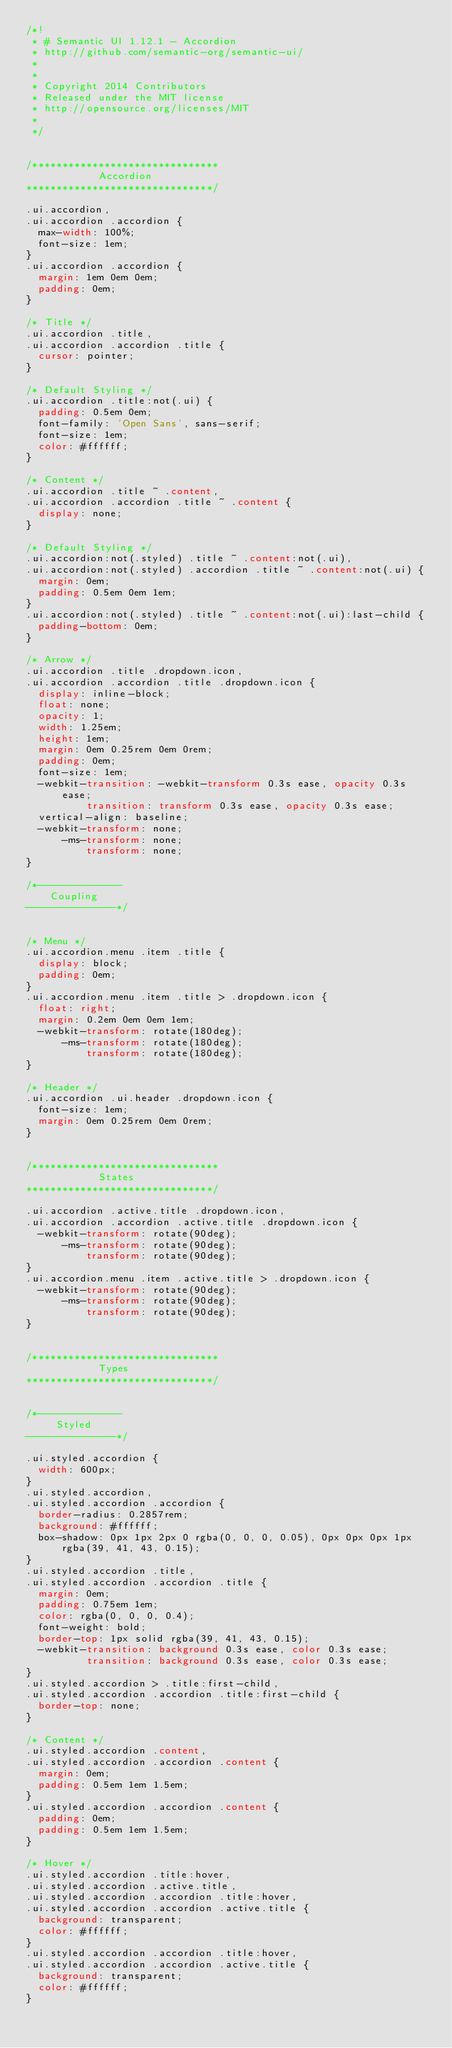<code> <loc_0><loc_0><loc_500><loc_500><_CSS_>/*!
 * # Semantic UI 1.12.1 - Accordion
 * http://github.com/semantic-org/semantic-ui/
 *
 *
 * Copyright 2014 Contributors
 * Released under the MIT license
 * http://opensource.org/licenses/MIT
 *
 */


/*******************************
            Accordion
*******************************/

.ui.accordion,
.ui.accordion .accordion {
  max-width: 100%;
  font-size: 1em;
}
.ui.accordion .accordion {
  margin: 1em 0em 0em;
  padding: 0em;
}

/* Title */
.ui.accordion .title,
.ui.accordion .accordion .title {
  cursor: pointer;
}

/* Default Styling */
.ui.accordion .title:not(.ui) {
  padding: 0.5em 0em;
  font-family: 'Open Sans', sans-serif;
  font-size: 1em;
  color: #ffffff;
}

/* Content */
.ui.accordion .title ~ .content,
.ui.accordion .accordion .title ~ .content {
  display: none;
}

/* Default Styling */
.ui.accordion:not(.styled) .title ~ .content:not(.ui),
.ui.accordion:not(.styled) .accordion .title ~ .content:not(.ui) {
  margin: 0em;
  padding: 0.5em 0em 1em;
}
.ui.accordion:not(.styled) .title ~ .content:not(.ui):last-child {
  padding-bottom: 0em;
}

/* Arrow */
.ui.accordion .title .dropdown.icon,
.ui.accordion .accordion .title .dropdown.icon {
  display: inline-block;
  float: none;
  opacity: 1;
  width: 1.25em;
  height: 1em;
  margin: 0em 0.25rem 0em 0rem;
  padding: 0em;
  font-size: 1em;
  -webkit-transition: -webkit-transform 0.3s ease, opacity 0.3s ease;
          transition: transform 0.3s ease, opacity 0.3s ease;
  vertical-align: baseline;
  -webkit-transform: none;
      -ms-transform: none;
          transform: none;
}

/*--------------
    Coupling
---------------*/


/* Menu */
.ui.accordion.menu .item .title {
  display: block;
  padding: 0em;
}
.ui.accordion.menu .item .title > .dropdown.icon {
  float: right;
  margin: 0.2em 0em 0em 1em;
  -webkit-transform: rotate(180deg);
      -ms-transform: rotate(180deg);
          transform: rotate(180deg);
}

/* Header */
.ui.accordion .ui.header .dropdown.icon {
  font-size: 1em;
  margin: 0em 0.25rem 0em 0rem;
}


/*******************************
            States
*******************************/

.ui.accordion .active.title .dropdown.icon,
.ui.accordion .accordion .active.title .dropdown.icon {
  -webkit-transform: rotate(90deg);
      -ms-transform: rotate(90deg);
          transform: rotate(90deg);
}
.ui.accordion.menu .item .active.title > .dropdown.icon {
  -webkit-transform: rotate(90deg);
      -ms-transform: rotate(90deg);
          transform: rotate(90deg);
}


/*******************************
            Types
*******************************/


/*--------------
     Styled
---------------*/

.ui.styled.accordion {
  width: 600px;
}
.ui.styled.accordion,
.ui.styled.accordion .accordion {
  border-radius: 0.2857rem;
  background: #ffffff;
  box-shadow: 0px 1px 2px 0 rgba(0, 0, 0, 0.05), 0px 0px 0px 1px rgba(39, 41, 43, 0.15);
}
.ui.styled.accordion .title,
.ui.styled.accordion .accordion .title {
  margin: 0em;
  padding: 0.75em 1em;
  color: rgba(0, 0, 0, 0.4);
  font-weight: bold;
  border-top: 1px solid rgba(39, 41, 43, 0.15);
  -webkit-transition: background 0.3s ease, color 0.3s ease;
          transition: background 0.3s ease, color 0.3s ease;
}
.ui.styled.accordion > .title:first-child,
.ui.styled.accordion .accordion .title:first-child {
  border-top: none;
}

/* Content */
.ui.styled.accordion .content,
.ui.styled.accordion .accordion .content {
  margin: 0em;
  padding: 0.5em 1em 1.5em;
}
.ui.styled.accordion .accordion .content {
  padding: 0em;
  padding: 0.5em 1em 1.5em;
}

/* Hover */
.ui.styled.accordion .title:hover,
.ui.styled.accordion .active.title,
.ui.styled.accordion .accordion .title:hover,
.ui.styled.accordion .accordion .active.title {
  background: transparent;
  color: #ffffff;
}
.ui.styled.accordion .accordion .title:hover,
.ui.styled.accordion .accordion .active.title {
  background: transparent;
  color: #ffffff;
}
</code> 